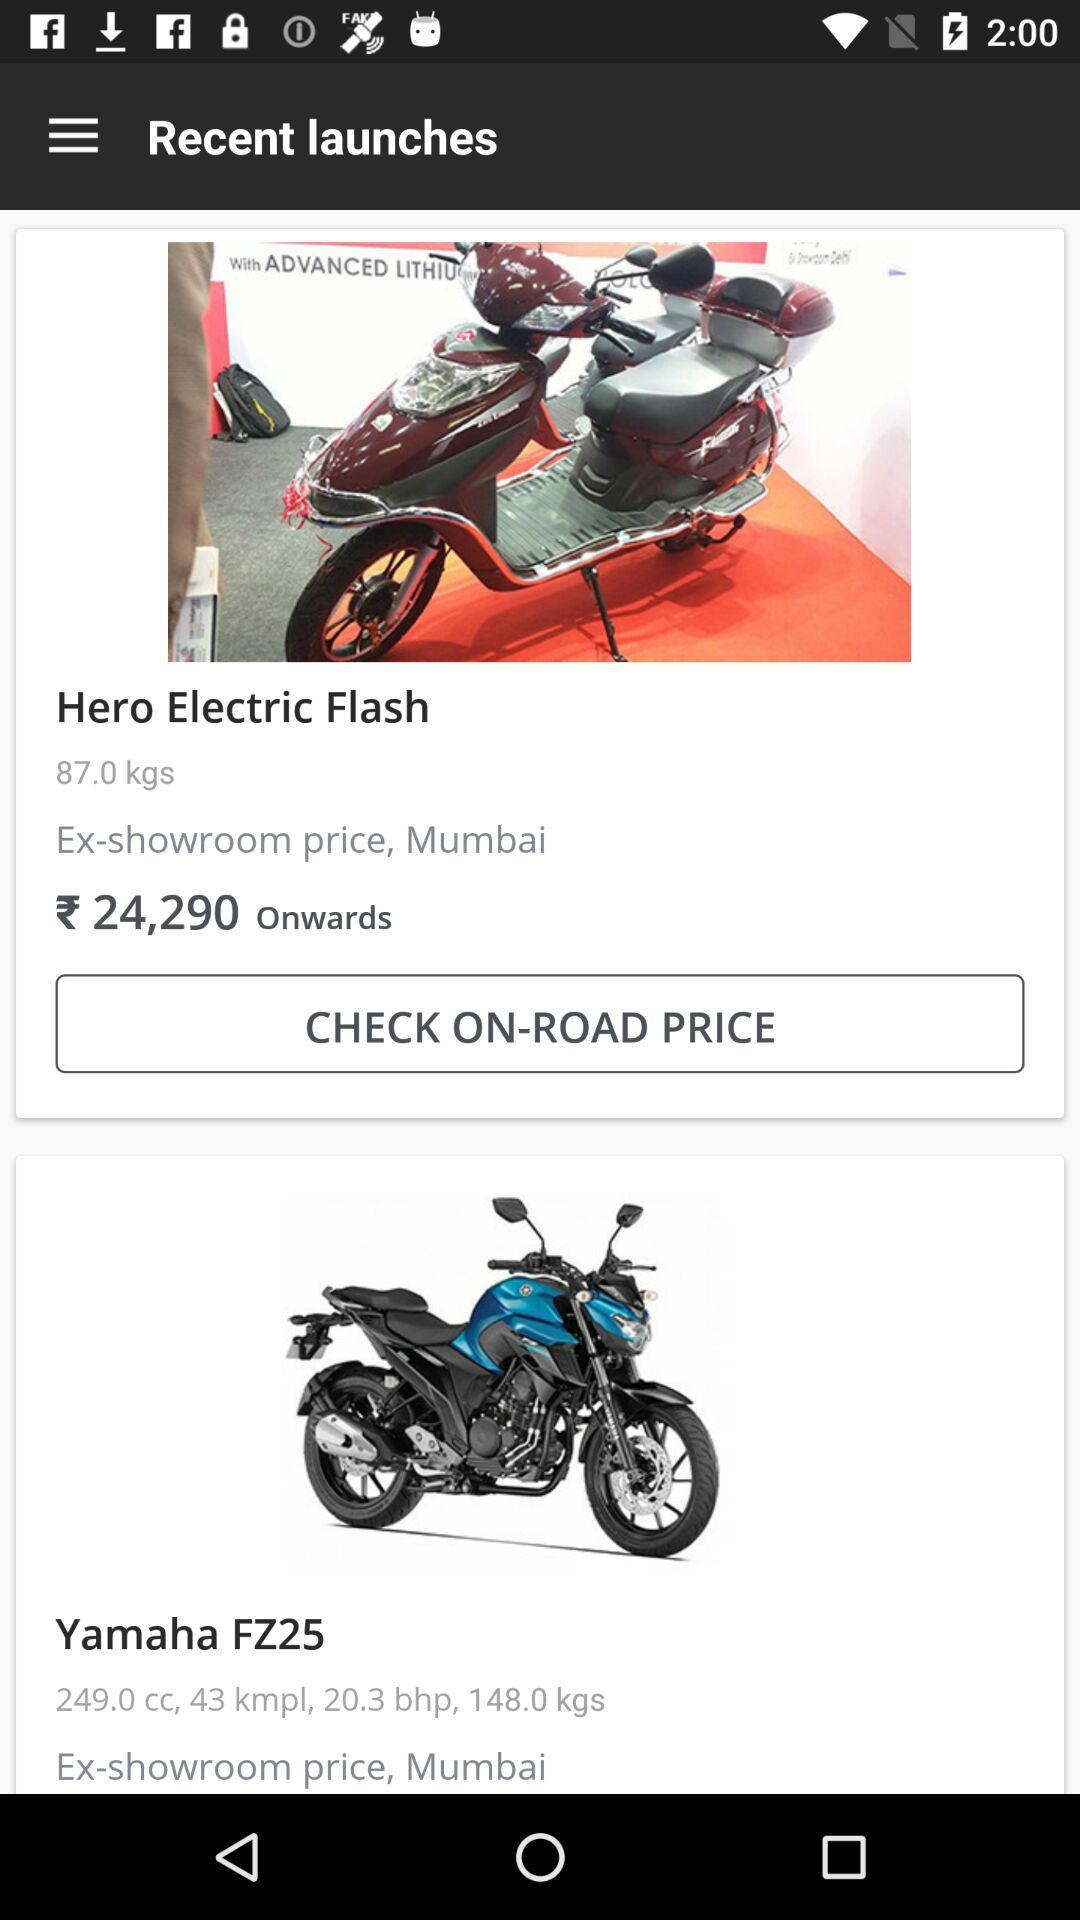What is the brake horsepower of the "Yamaha FZ25"? The brake horsepower of the "Yamaha FZ25" is 20.3. 